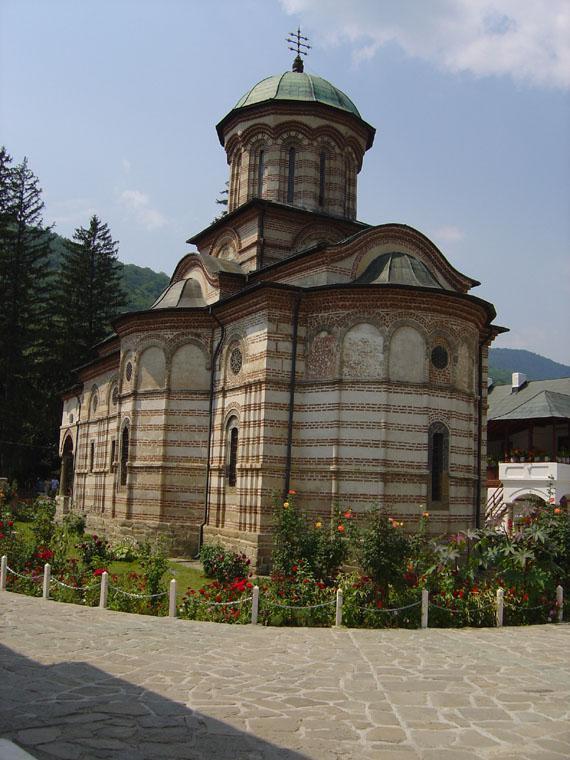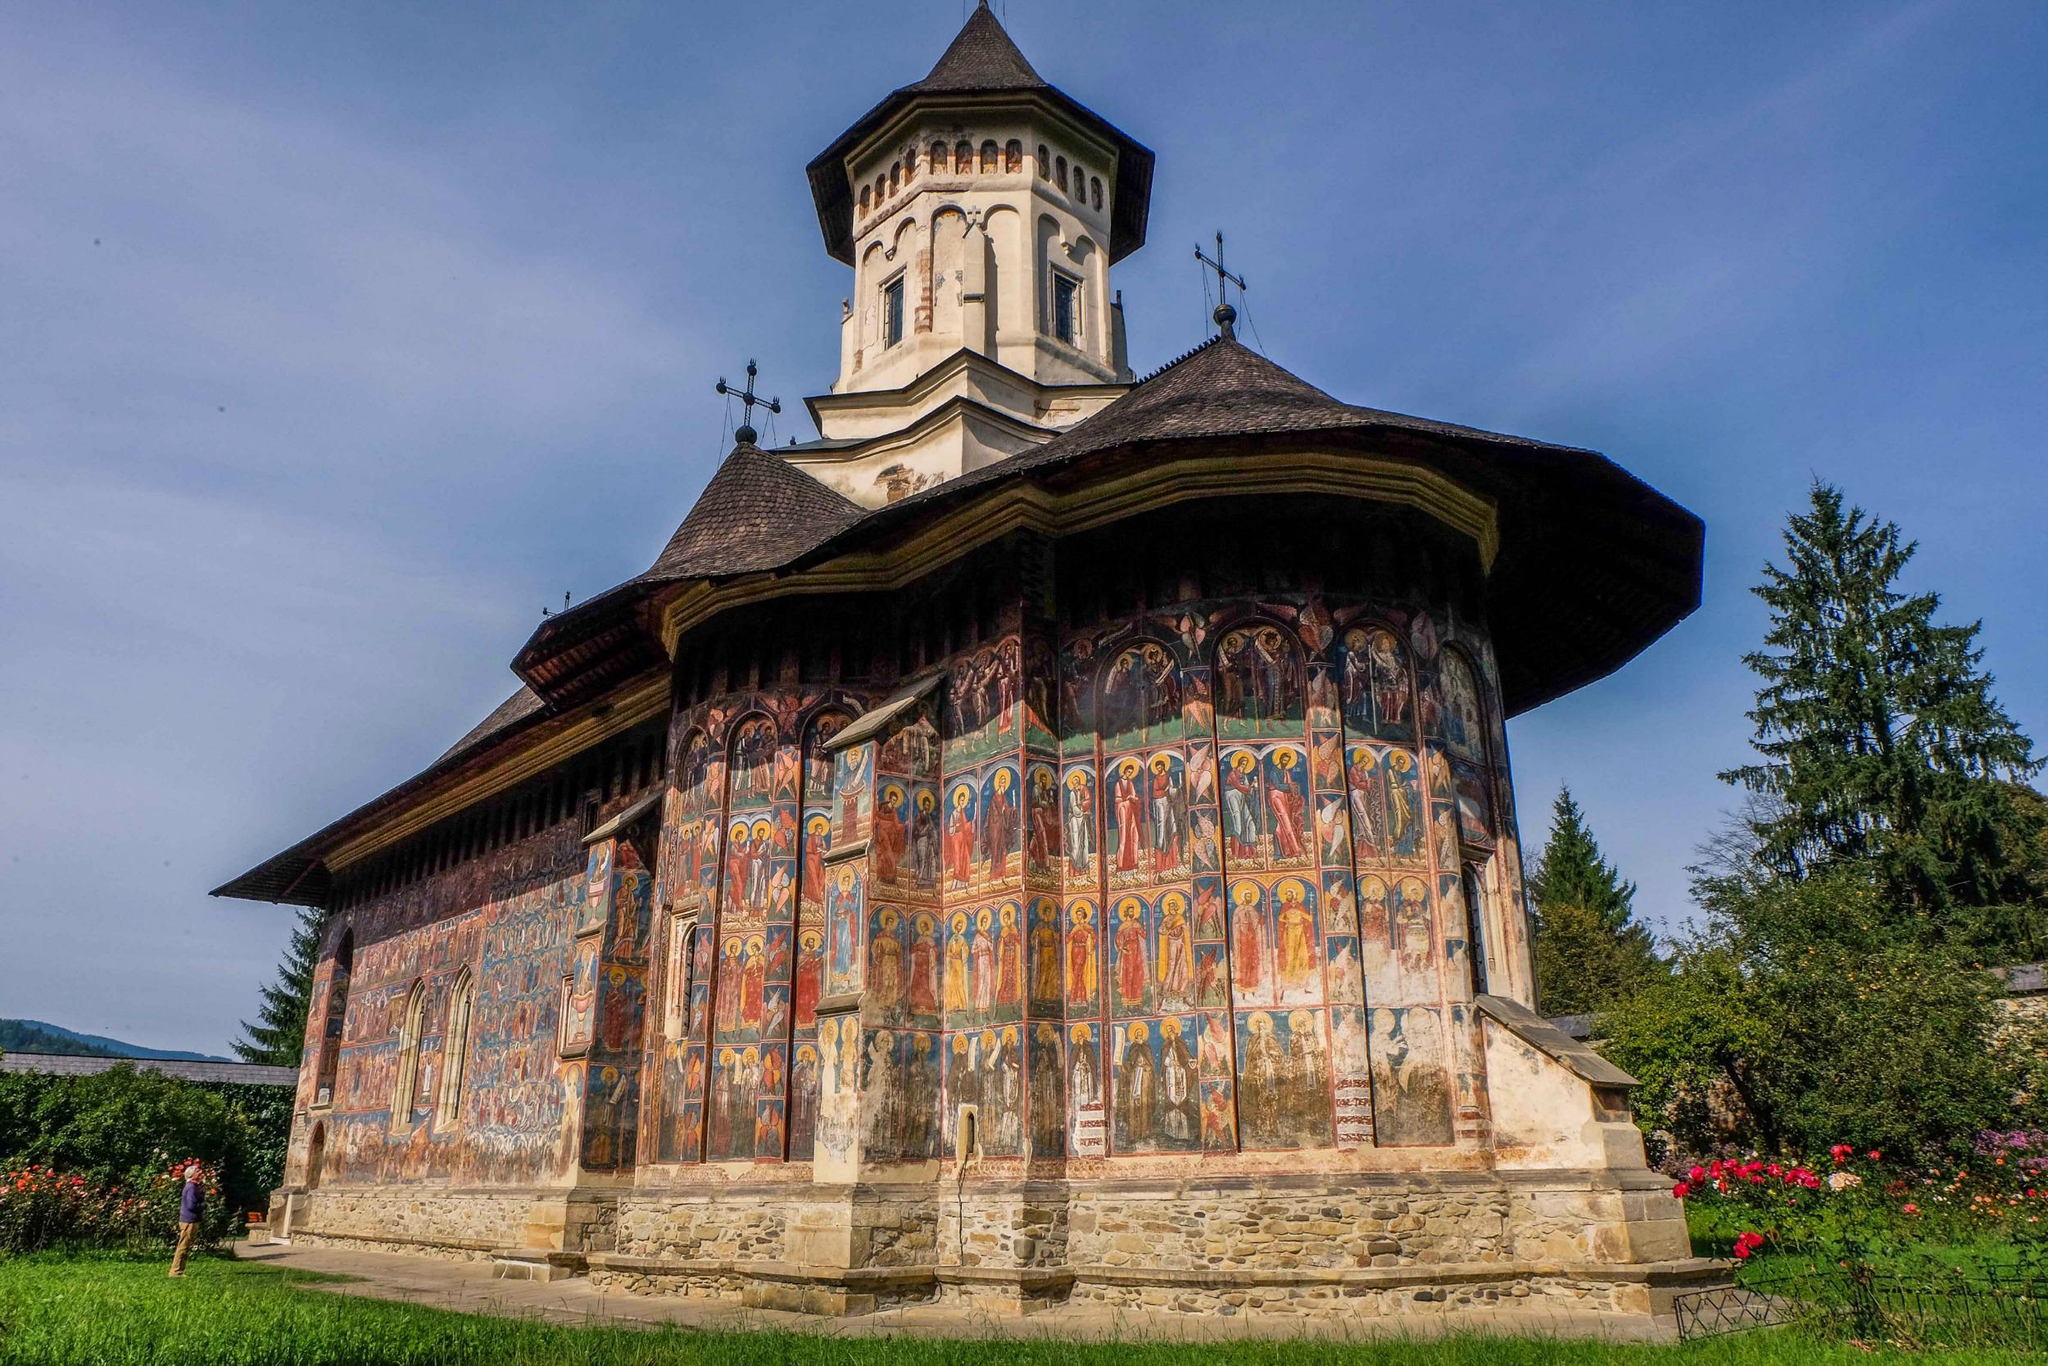The first image is the image on the left, the second image is the image on the right. For the images displayed, is the sentence "You can see a lawn surrounding the church in both images." factually correct? Answer yes or no. Yes. 